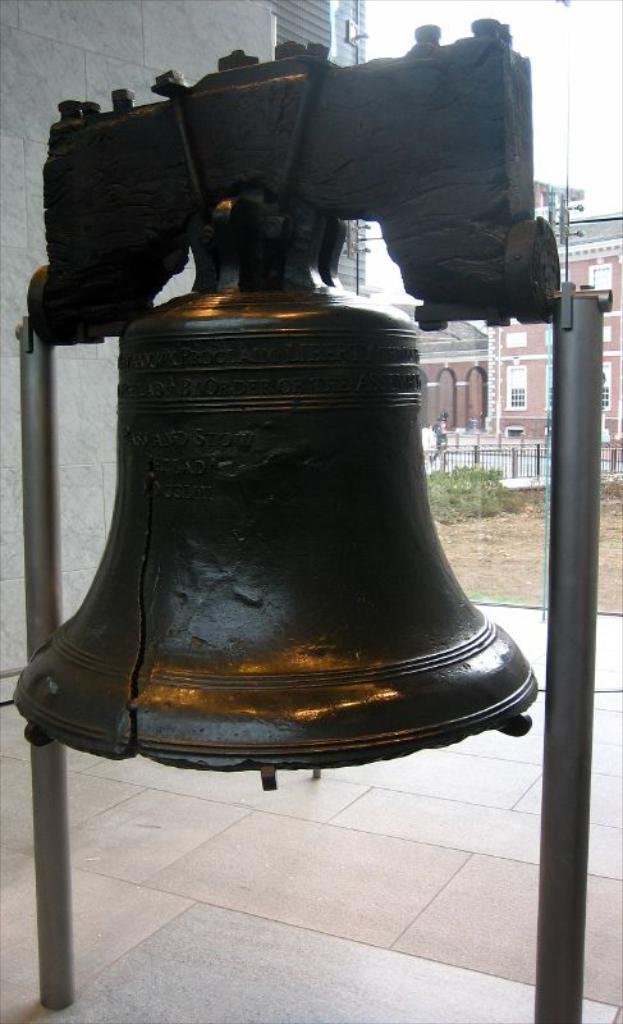What is the main object in the image? There is a bell with stands in the image. What is located behind the bell? There is a fence behind the bell. What can be seen behind the fence? Plants are visible behind the fence. What is visible in the background of the image? There are buildings and the sky in the background of the image. What type of education can be seen taking place in the image? There is no indication of any educational activity in the image; it primarily features a bell with stands and its surrounding environment. 